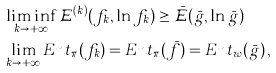<formula> <loc_0><loc_0><loc_500><loc_500>& \liminf _ { k \rightarrow + \infty } \mathcal { E } ^ { ( k ) } ( f _ { k } , \ln f _ { k } ) \geq \bar { \mathcal { E } } ( \bar { g } , \ln \bar { g } ) \, \\ & \lim _ { k \rightarrow + \infty } E n t _ { \pi } ( f _ { k } ) = E n t _ { \pi } ( \bar { f } ) = E n t _ { w } ( \bar { g } ) \, ,</formula> 